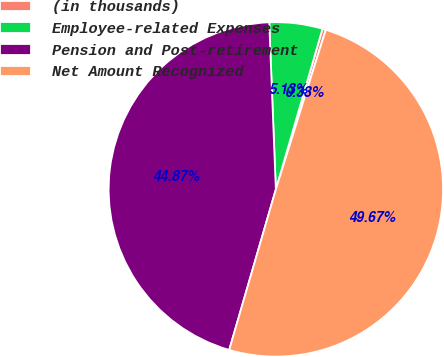<chart> <loc_0><loc_0><loc_500><loc_500><pie_chart><fcel>(in thousands)<fcel>Employee-related Expenses<fcel>Pension and Post-retirement<fcel>Net Amount Recognized<nl><fcel>0.33%<fcel>5.13%<fcel>44.87%<fcel>49.67%<nl></chart> 